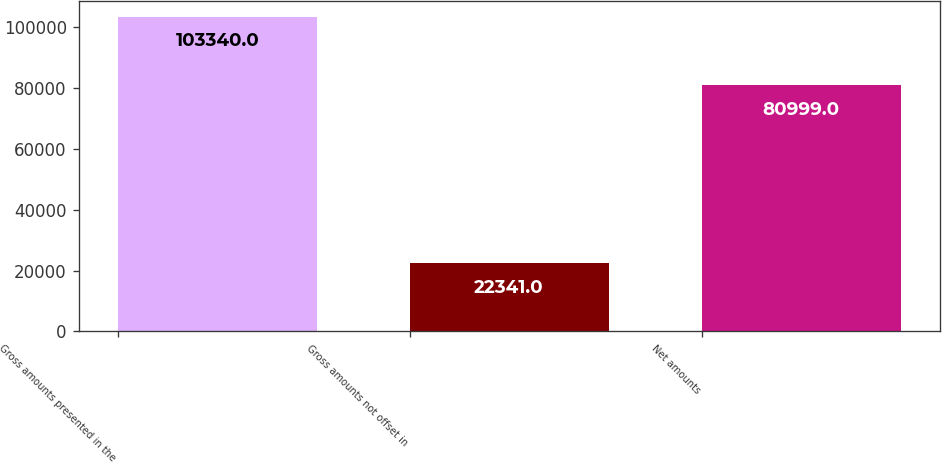Convert chart. <chart><loc_0><loc_0><loc_500><loc_500><bar_chart><fcel>Gross amounts presented in the<fcel>Gross amounts not offset in<fcel>Net amounts<nl><fcel>103340<fcel>22341<fcel>80999<nl></chart> 